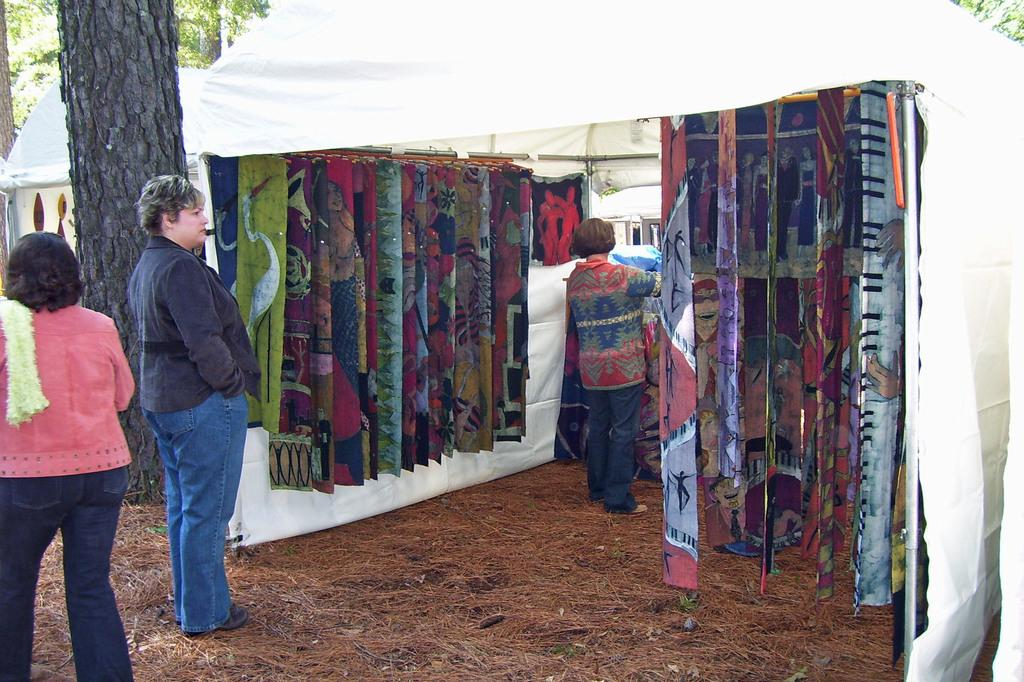What type of shop is shown in the image? The image depicts an open cloth shop. Can you describe the woman standing in front of the shop? The woman is wearing a black jacket and is watching the cloth. What can be seen in the background of the image? There is a tree trunk visible in the background. What type of grass is growing near the woman in the image? There is no grass visible in the image; it is set in front of a cloth shop. Can you tell me the story behind the woman's decision to watch the cloth? The image does not provide any information about the woman's motivations or the story behind her actions. Is there a calculator visible in the image? There is no calculator present in the image. 